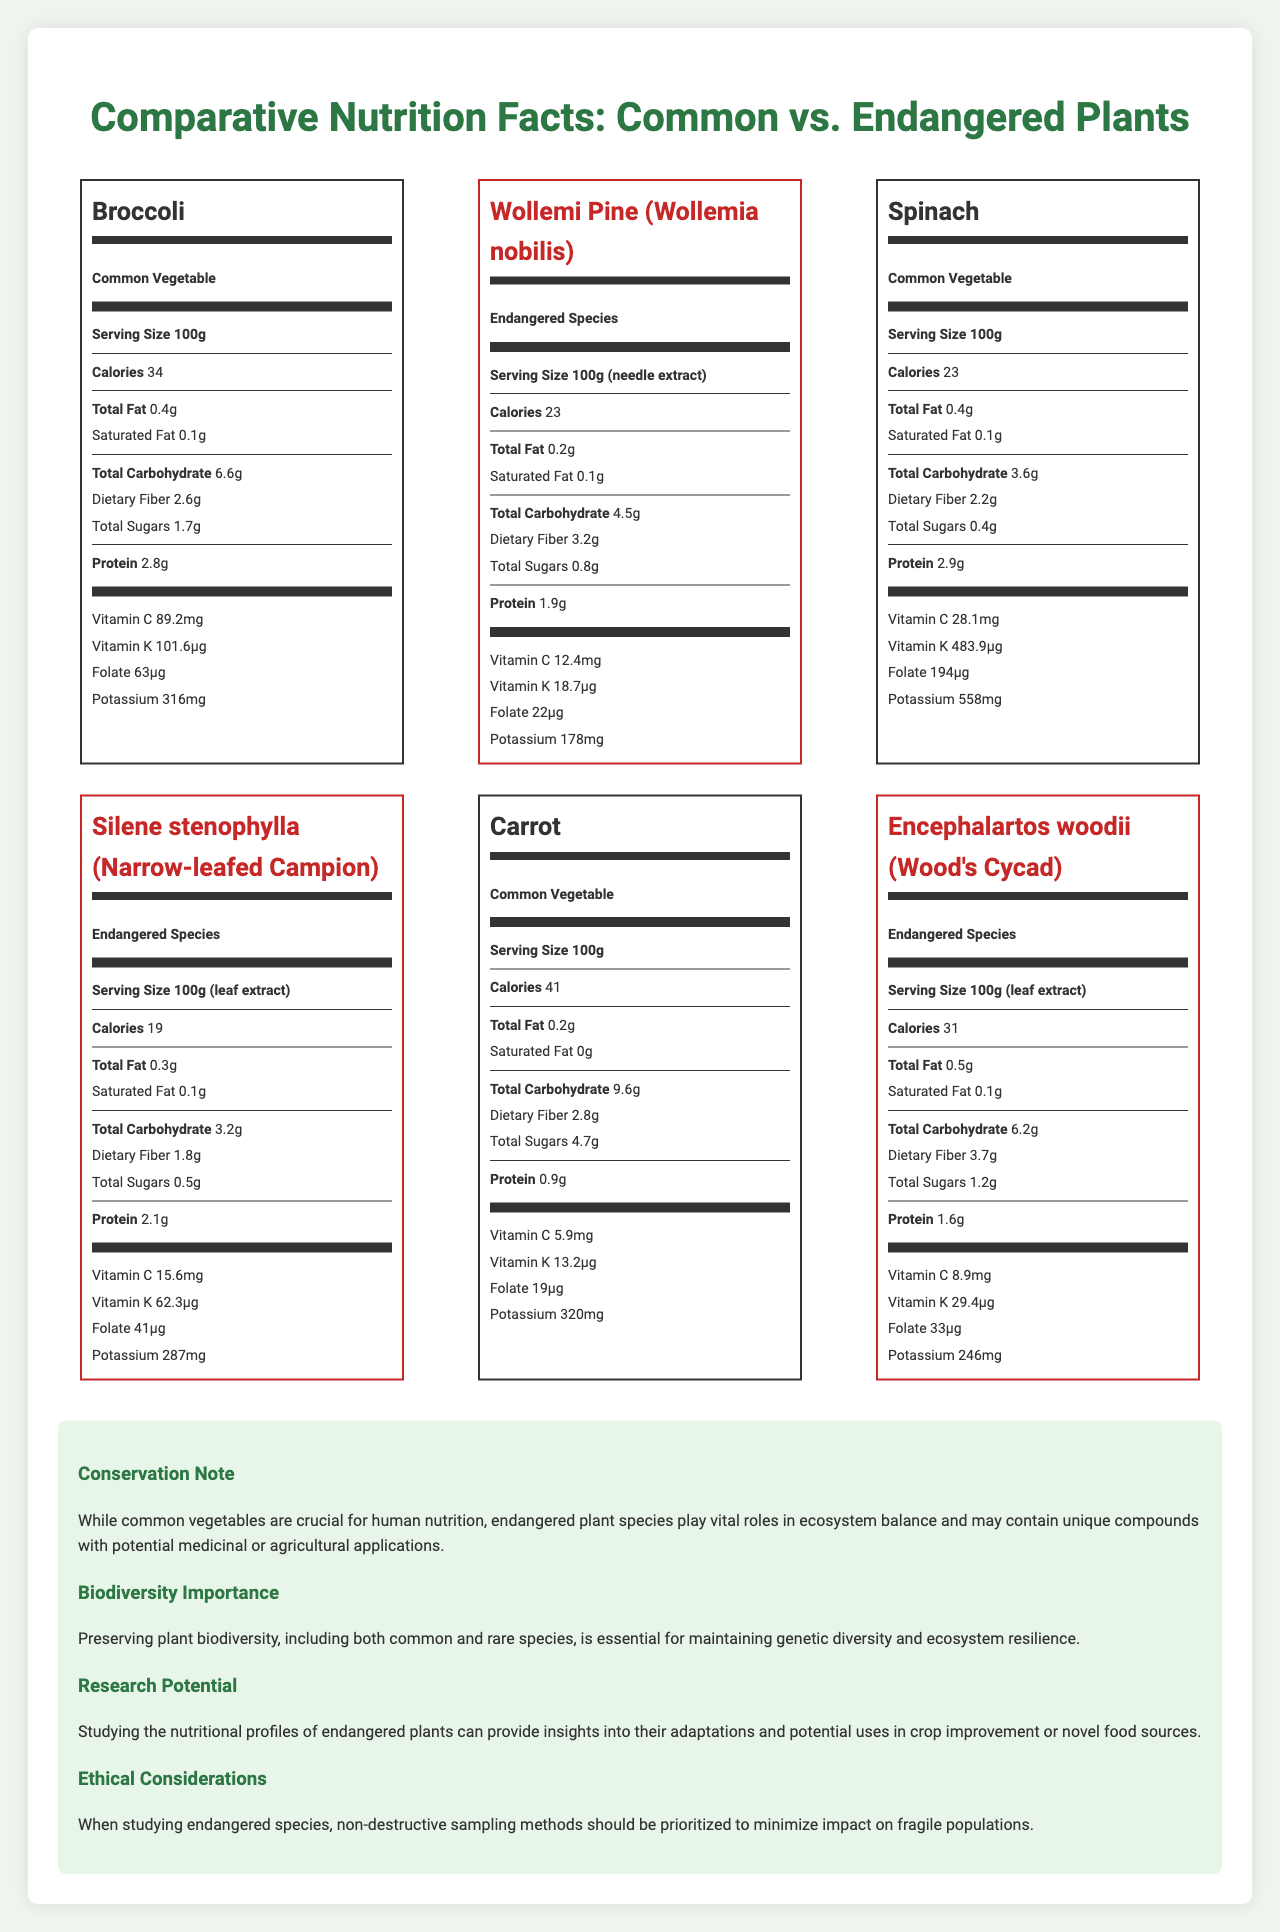what is the serving size of Broccoli? The serving size is listed under the name "Broccoli".
Answer: 100g Which common vegetable has the highest amount of Vitamin C? A. Broccoli B. Spinach C. Carrot Broccoli has 89.2mg of Vitamin C, which is higher than Spinach (28.1mg) and Carrot (5.9mg).
Answer: A What is the total carbohydrate content in Wollemi Pine needle extract? The total carbohydrate content is listed under the nutritional information for Wollemi Pine (Wollemia nobilis).
Answer: 4.5g Is the fiber content of Wood's Cycad leaf extract higher than that of Broccoli? Wood's Cycad leaf extract has 3.7g of fiber, whereas Broccoli has only 2.6g.
Answer: Yes What plant has the highest potassium content? Spinach has 558mg of potassium, higher than any other plants listed.
Answer: Spinach which plant has the lowest calorie count? A. Broccoli B. Wollemi Pine C. Spinach D. Silene stenophylla Silene stenophylla has 19 calories, which is lower than Broccoli (34), Wollemi Pine (23), Spinach (23).
Answer: D Does Silene stenophylla leaf extract have more protein than Carrot? Silene stenophylla leaf extract has 2.1g of protein, while Carrot has only 0.9g.
Answer: Yes Summarize the main idea of the entire document. The document showcases the nutritional profiles of various common vegetables and endangered plants, emphasizing the importance of both for human nutrition, ecosystem balance, genetic diversity, and potential research benefits. It also advises ethical considerations for studying endangered species.
Answer: The document provides comparative nutrition facts for common vegetables and endangered plant species, highlighting their nutritional content, conservation importance, biodiversity, and research potential. Which plant type has a higher average fiber content, common vegetables or endangered species? The average fiber content for endangered species is higher due to high fiber content for plants like Encephalartos woodii (3.7g) compared to common vegetables.
Answer: Endangered Species What conservation note is mentioned in the document? This note is found in the additional information section under "Conservation Note".
Answer: Common vegetables are crucial for human nutrition, but endangered plant species play vital roles in ecosystem balance and may contain unique compounds with potential medicinal or agricultural applications. What is the significance of studying the nutritional profiles of endangered plants according to the document? This is highlighted in the section titled "Research Potential".
Answer: It provides insights into their adaptations and potential uses in crop improvement or novel food sources. Name two vitamins found in Broccoli. These vitamins are listed under Broccoli's nutritional information.
Answer: Vitamin C and Vitamin K Which plant has the highest amount of folate? Spinach contains 194µg of folate, which is the highest among the listed plants.
Answer: Spinach Can the endangered species listed in the document be directly consumed by humans? The document provides nutritional facts for plant extracts and does not specify their direct consumability.
Answer: Not enough information 